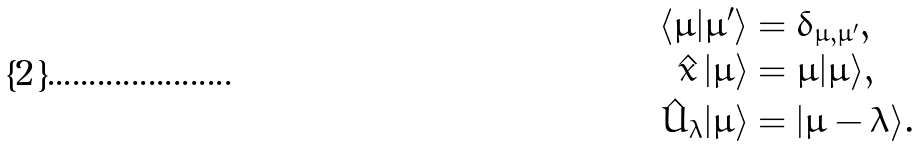<formula> <loc_0><loc_0><loc_500><loc_500>\langle \mu | \mu ^ { \prime } \rangle & = \delta _ { \mu , \mu ^ { \prime } } , \\ \hat { x } \, | \mu \rangle & = \mu | \mu \rangle , \\ \hat { U } _ { \lambda } | \mu \rangle & = | \mu - \lambda \rangle .</formula> 